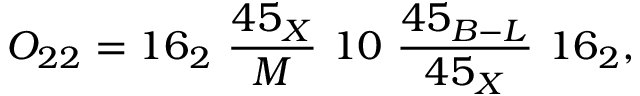<formula> <loc_0><loc_0><loc_500><loc_500>O _ { 2 2 } = 1 6 _ { 2 } \ { \frac { 4 5 _ { X } } { M } } \ 1 0 \ { \frac { 4 5 _ { B - L } } { 4 5 _ { X } } } \ 1 6 _ { 2 } ,</formula> 